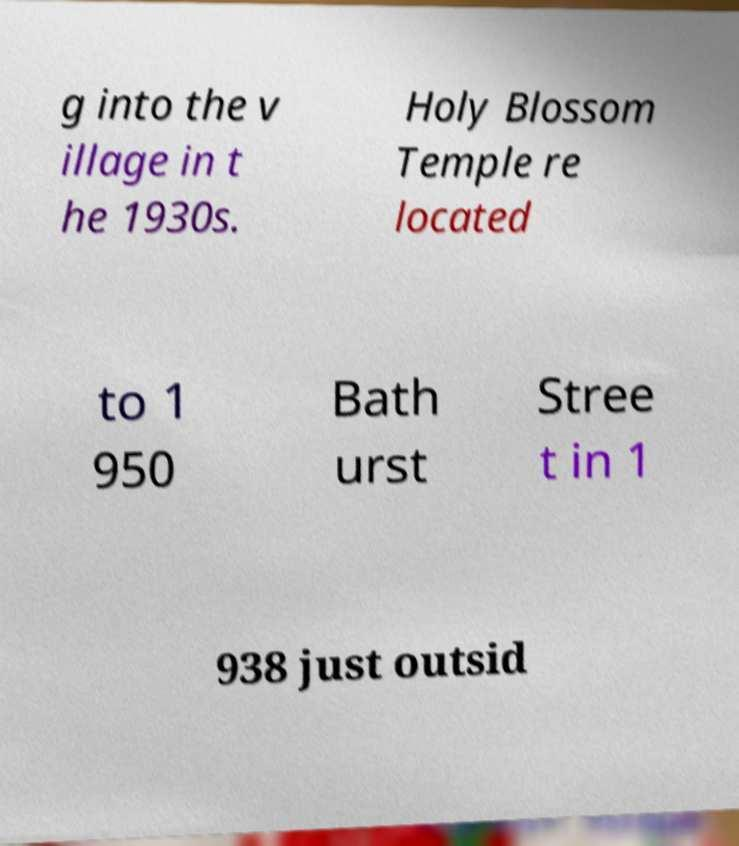What messages or text are displayed in this image? I need them in a readable, typed format. g into the v illage in t he 1930s. Holy Blossom Temple re located to 1 950 Bath urst Stree t in 1 938 just outsid 